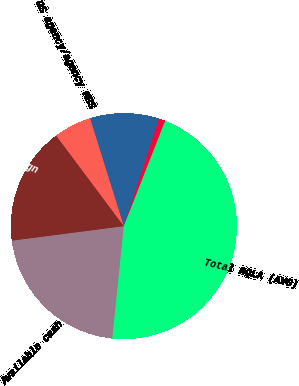Convert chart. <chart><loc_0><loc_0><loc_500><loc_500><pie_chart><fcel>Available cash<fcel>US sovereign<fcel>US agency/agency MBS<fcel>Foreign government debt (1)<fcel>Other investment grade<fcel>Total HQLA (AVG)<nl><fcel>21.32%<fcel>16.84%<fcel>5.39%<fcel>9.87%<fcel>0.91%<fcel>45.68%<nl></chart> 